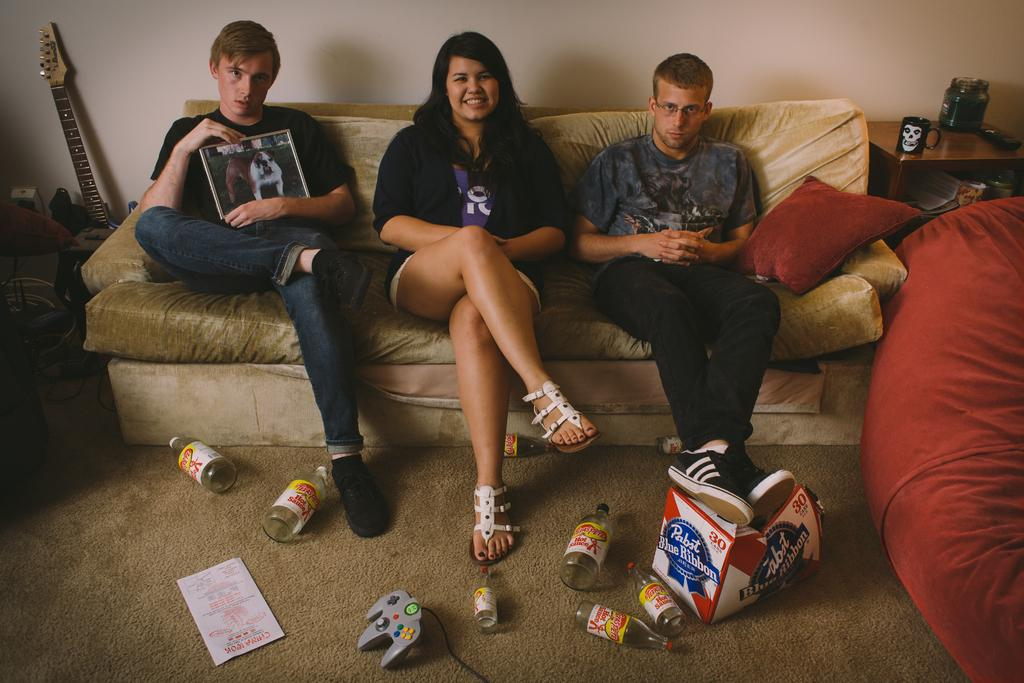<image>
Summarize the visual content of the image. Three people sit on the couch with an empty box of Pabst Blue Ribbon beer on the floor. 